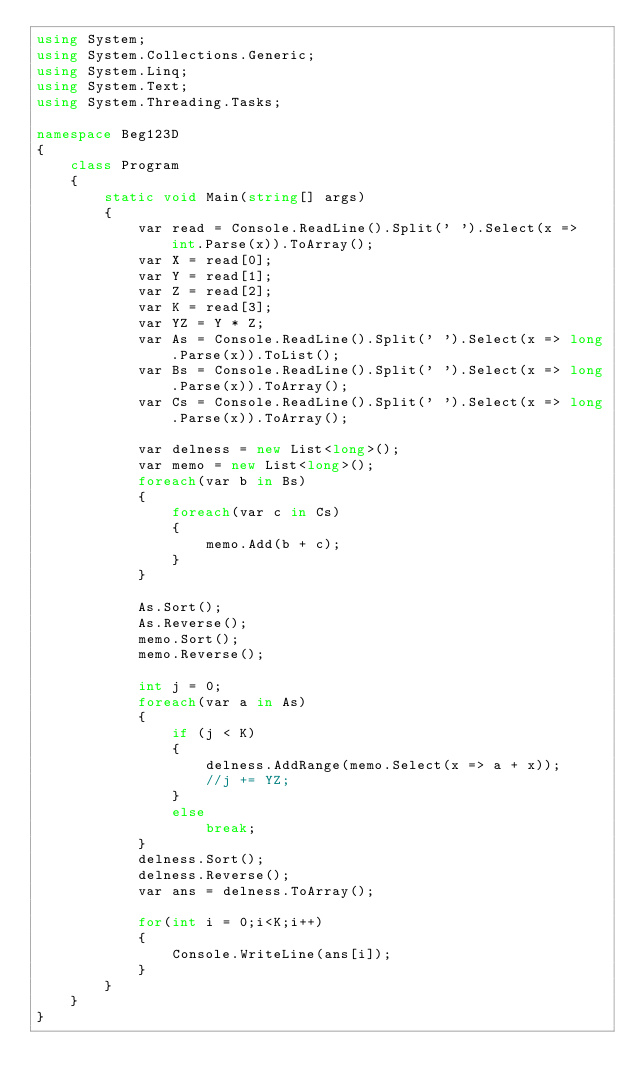Convert code to text. <code><loc_0><loc_0><loc_500><loc_500><_C#_>using System;
using System.Collections.Generic;
using System.Linq;
using System.Text;
using System.Threading.Tasks;

namespace Beg123D
{
    class Program
    {
        static void Main(string[] args)
        {
            var read = Console.ReadLine().Split(' ').Select(x => int.Parse(x)).ToArray();
            var X = read[0];
            var Y = read[1];
            var Z = read[2];
            var K = read[3];
            var YZ = Y * Z;
            var As = Console.ReadLine().Split(' ').Select(x => long.Parse(x)).ToList();
            var Bs = Console.ReadLine().Split(' ').Select(x => long.Parse(x)).ToArray();
            var Cs = Console.ReadLine().Split(' ').Select(x => long.Parse(x)).ToArray();

            var delness = new List<long>();
            var memo = new List<long>();
            foreach(var b in Bs)
            {
                foreach(var c in Cs)
                {
                    memo.Add(b + c);
                }
            }

            As.Sort();
            As.Reverse();
            memo.Sort();
            memo.Reverse();

            int j = 0;
            foreach(var a in As)
            {
                if (j < K)
                {
                    delness.AddRange(memo.Select(x => a + x));
                    //j += YZ;
                }
                else
                    break;
            }
            delness.Sort();
            delness.Reverse();
            var ans = delness.ToArray();

            for(int i = 0;i<K;i++)
            {
                Console.WriteLine(ans[i]);
            }
        }
    }
}
</code> 